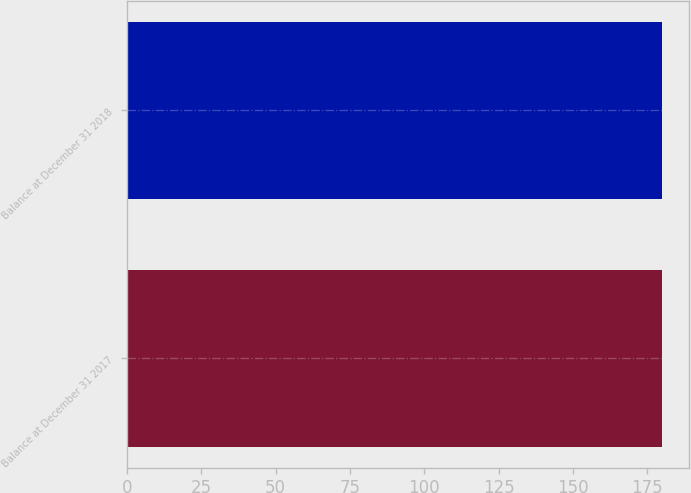Convert chart. <chart><loc_0><loc_0><loc_500><loc_500><bar_chart><fcel>Balance at December 31 2017<fcel>Balance at December 31 2018<nl><fcel>180<fcel>180.1<nl></chart> 